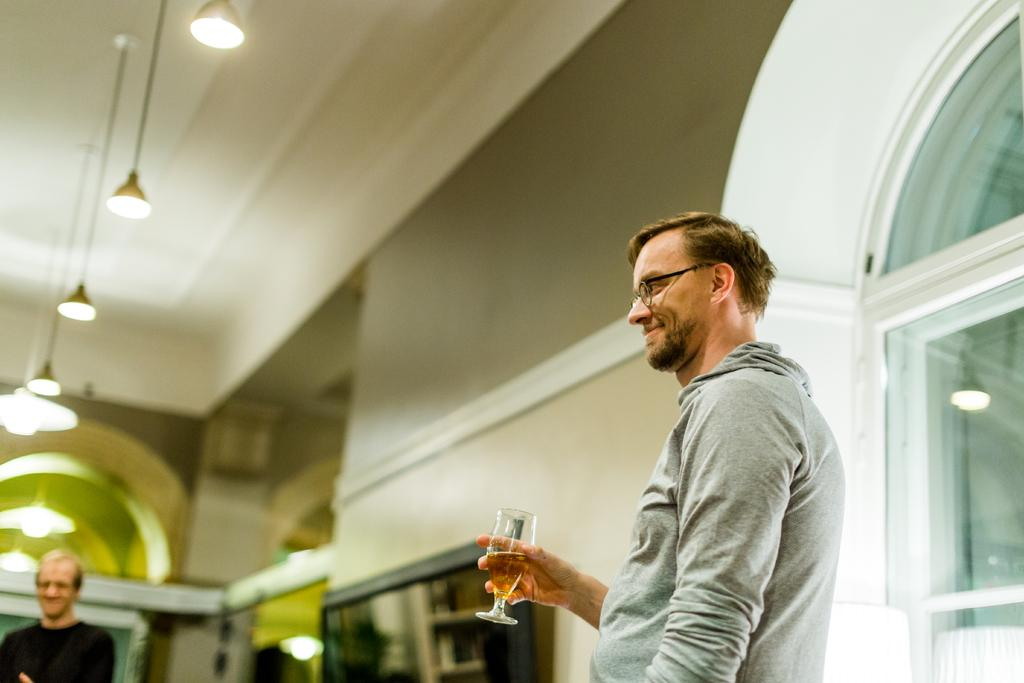What is the person in the image doing? The person is standing in the image and holding a wine glass. What can be seen in the background of the image? There is a wall, a ceiling, and lights visible in the background of the image. Are there any other people in the image? Yes, there is another person in the background of the image. What type of jellyfish can be seen swimming in the background of the image? There are no jellyfish present in the image; it features a person holding a wine glass and a background with a wall, ceiling, and lights. How many cars are visible in the image? There are no cars visible in the image. 